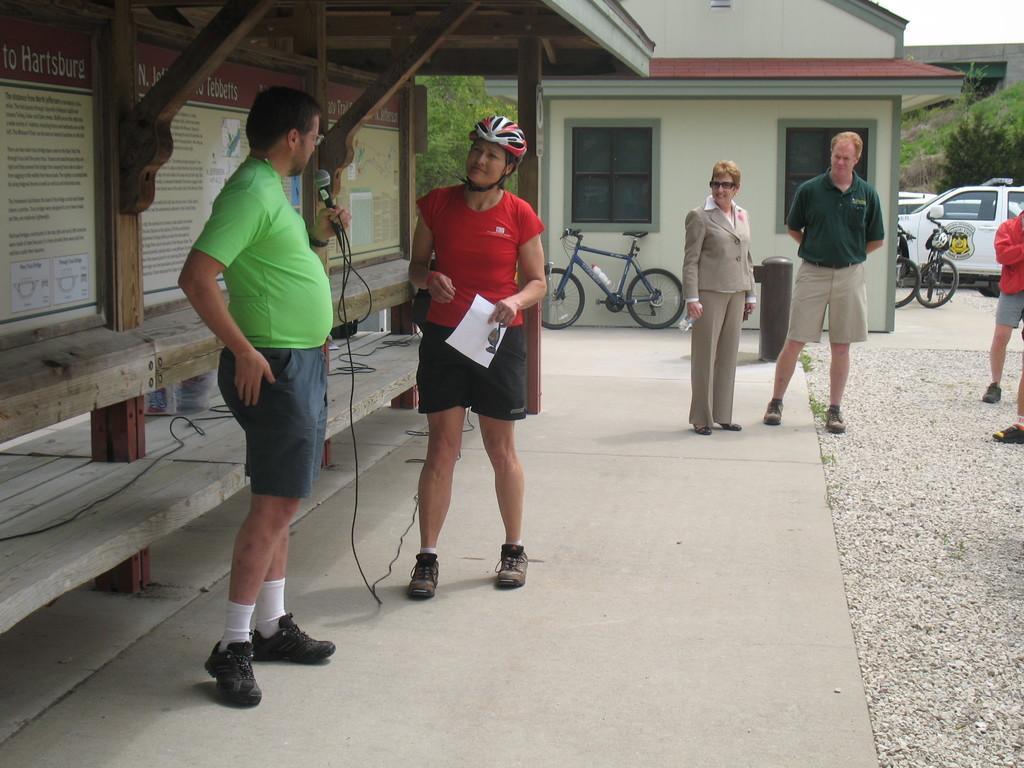Could you give a brief overview of what you see in this image? In this image we can see few persons standing on the land and there is a person holding the mike and standing under the roof. In the background we can see houses, trees, cars and also some bicycles. 